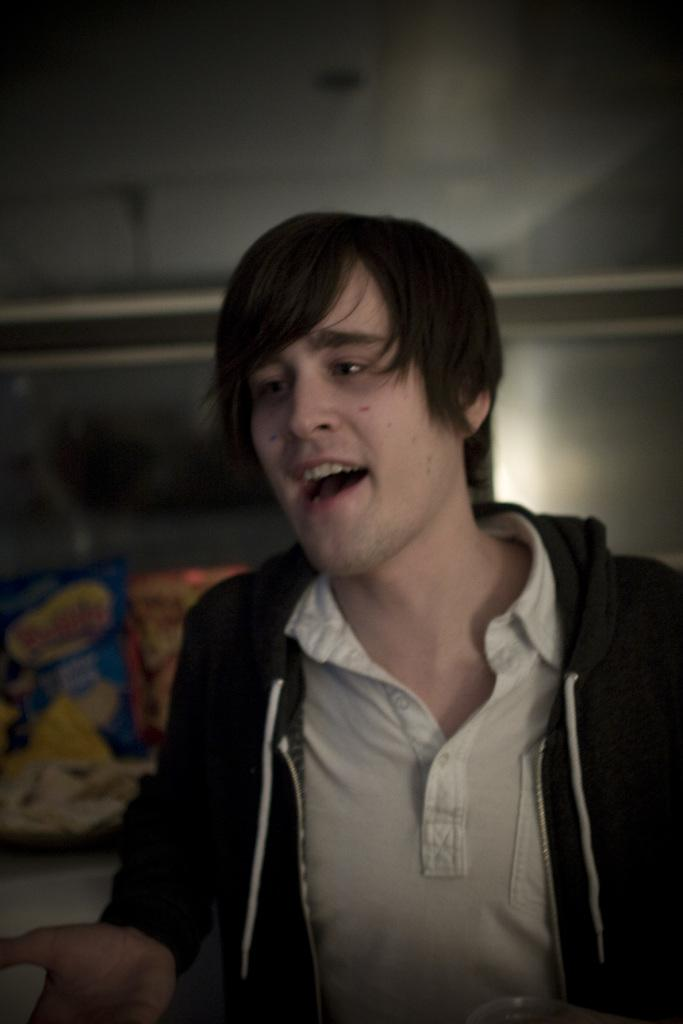Who is present in the image? There is a man in the image. What is the man wearing? The man is wearing a jacket. What type of argument is the man having with the bed in the image? There is no bed present in the image, and therefore no argument can be observed. 